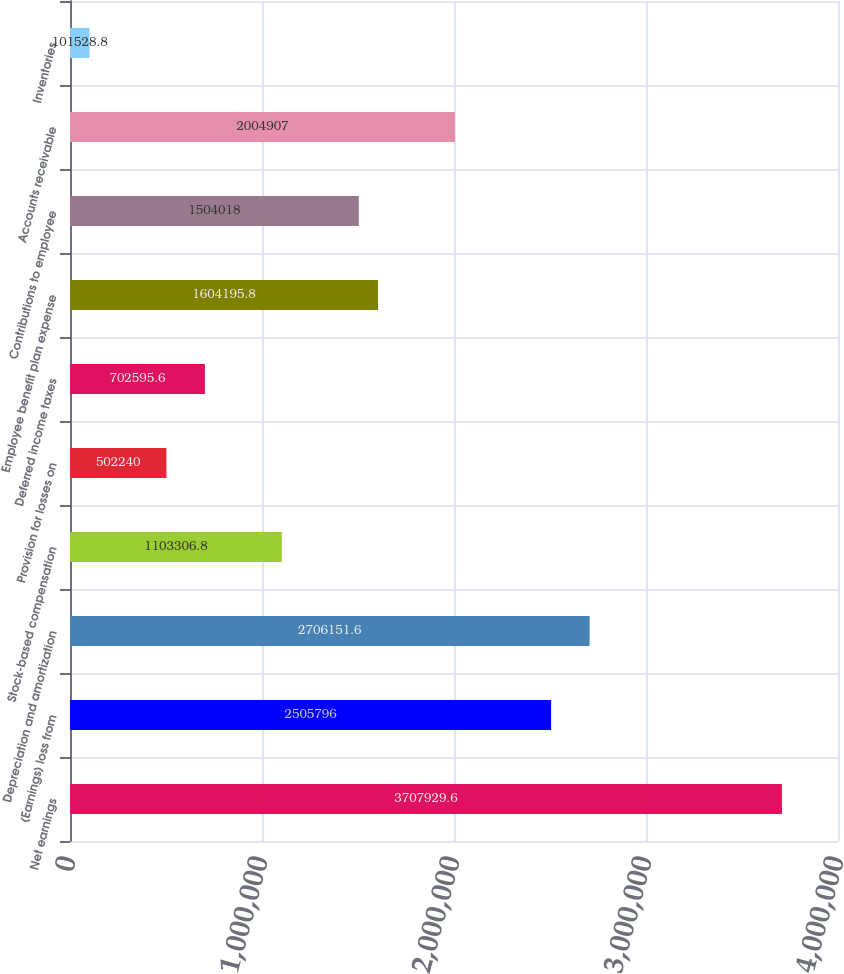Convert chart. <chart><loc_0><loc_0><loc_500><loc_500><bar_chart><fcel>Net earnings<fcel>(Earnings) loss from<fcel>Depreciation and amortization<fcel>Stock-based compensation<fcel>Provision for losses on<fcel>Deferred income taxes<fcel>Employee benefit plan expense<fcel>Contributions to employee<fcel>Accounts receivable<fcel>Inventories<nl><fcel>3.70793e+06<fcel>2.5058e+06<fcel>2.70615e+06<fcel>1.10331e+06<fcel>502240<fcel>702596<fcel>1.6042e+06<fcel>1.50402e+06<fcel>2.00491e+06<fcel>101529<nl></chart> 